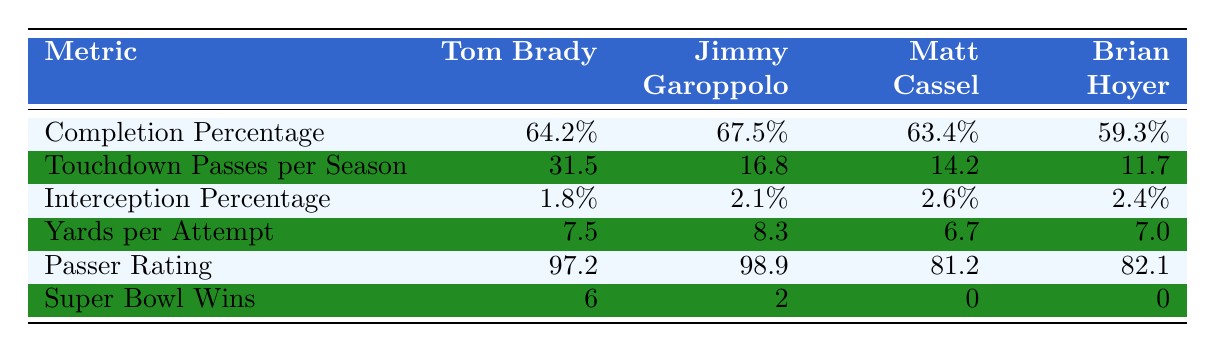What is Tom Brady's completion percentage? From the table, Tom Brady's completion percentage is listed under the "Completion Percentage" metric in the corresponding row. His completion percentage is 64.2%.
Answer: 64.2% Which quarterback has the highest touchdown passes per season? Referring to the "Touchdown Passes per Season" row, Tom Brady has the highest number at 31.5 touchdowns per season compared to Jimmy Garoppolo (16.8), Matt Cassel (14.2), and Brian Hoyer (11.7).
Answer: Tom Brady What is the average interception percentage of the quarterbacks listed? To find the average, add all the interception percentages: (1.8% + 2.1% + 2.6% + 2.4%) = 8.9%. Then, divide by the number of quarterbacks (4): 8.9% / 4 = 2.225%.
Answer: 2.225% Is it true that all quarterbacks coached by the same mentor have at least one Super Bowl win? Checking the "Super Bowl Wins" row, only Tom Brady has wins (6), while Jimmy Garoppolo, Matt Cassel, and Brian Hoyer have zero. Therefore, the statement is false.
Answer: No Which quarterback has the lowest yards per attempt, and what is that value? The "Yards per Attempt" row indicates that Matt Cassel has the lowest yards per attempt at 6.7.
Answer: Matt Cassel, 6.7 How does Tom Brady's passer rating compare to that of Brian Hoyer? Looking at the "Passer Rating" row, Tom Brady's passer rating is 97.2 while Brian Hoyer's is 82.1. The difference is 97.2 - 82.1 = 15.1. Thus, Tom Brady has a significantly higher passer rating than Brian Hoyer.
Answer: Tom Brady's passer rating is higher by 15.1 If we add the total Super Bowl wins of all quarterbacks mentioned, what is the total? Adding up the Super Bowl wins: 6 (Brady) + 2 (Garoppolo) + 0 (Cassel) + 0 (Hoyer) = 8 total Super Bowl wins.
Answer: 8 What percentage of touchdown passes per season does Jimmy Garoppolo have compared to Tom Brady? Jimmy Garoppolo's touchdown passes per season is 16.8, while Tom Brady has 31.5. To find the percentage: (16.8 / 31.5) * 100 = 53.33%. Garoppolo has about 53.33% of Brady's touchdowns.
Answer: 53.33% 